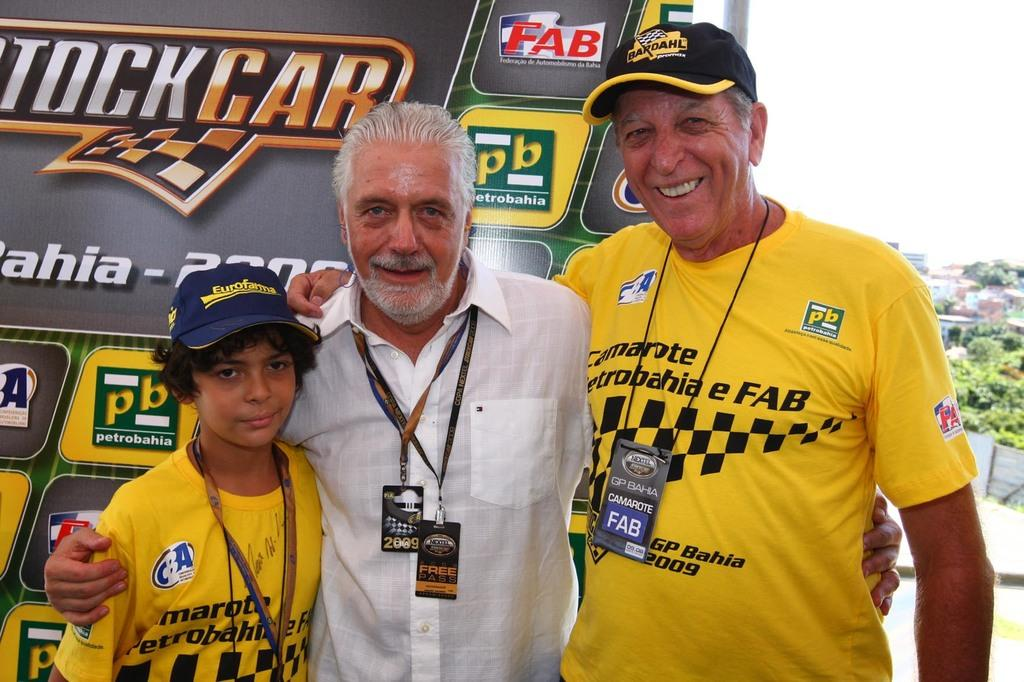<image>
Offer a succinct explanation of the picture presented. Man wearing a yellow shirt that says "FAB" posing for a photo. 